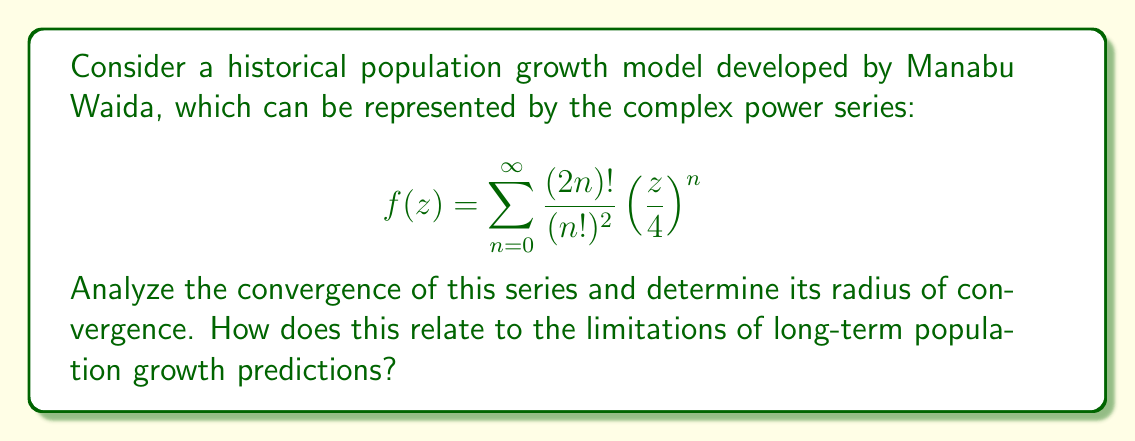Could you help me with this problem? To analyze the convergence of this complex power series, we'll use the ratio test:

1) First, let's define $a_n = \frac{(2n)!}{(n!)^2} \left(\frac{1}{4}\right)^n$

2) Now, we'll calculate the limit of the ratio of consecutive terms:

   $$\lim_{n \to \infty} \left|\frac{a_{n+1}}{a_n}\right| = \lim_{n \to \infty} \left|\frac{\frac{(2n+2)!}{((n+1)!)^2} \left(\frac{1}{4}\right)^{n+1}}{\frac{(2n)!}{(n!)^2} \left(\frac{1}{4}\right)^n}\right|$$

3) Simplify:
   
   $$\lim_{n \to \infty} \left|\frac{(2n+2)(2n+1)}{(n+1)^2} \cdot \frac{1}{4}\right|$$

4) As $n$ approaches infinity, this limit becomes:

   $$\lim_{n \to \infty} \left|\frac{4n^2+6n+2}{n^2+2n+1} \cdot \frac{1}{4}\right| = 1$$

5) Since the limit is 1, the radius of convergence is exactly 1.

This means the series converges for all $|z| < 1$ and diverges for all $|z| > 1$. At $|z| = 1$, further investigation would be needed to determine convergence.

Relating this to population growth, the radius of convergence being 1 suggests that this model has limitations for long-term predictions. As the input variable (which might represent time or another factor) approaches or exceeds the radius of convergence, the model becomes unreliable or diverges entirely. This aligns with the understanding that exponential growth models often break down over extended periods due to resource limitations, environmental factors, or other constraints.

Manabu Waida, being aware of these mathematical limitations, would likely have cautioned against over-reliance on such models for far-future population predictions. This mathematical insight supports the historical perspective that long-term demographic forecasts should be approached with careful consideration of their inherent uncertainties and limitations.
Answer: The radius of convergence for the given complex power series is 1. The series converges for $|z| < 1$ and diverges for $|z| > 1$. 